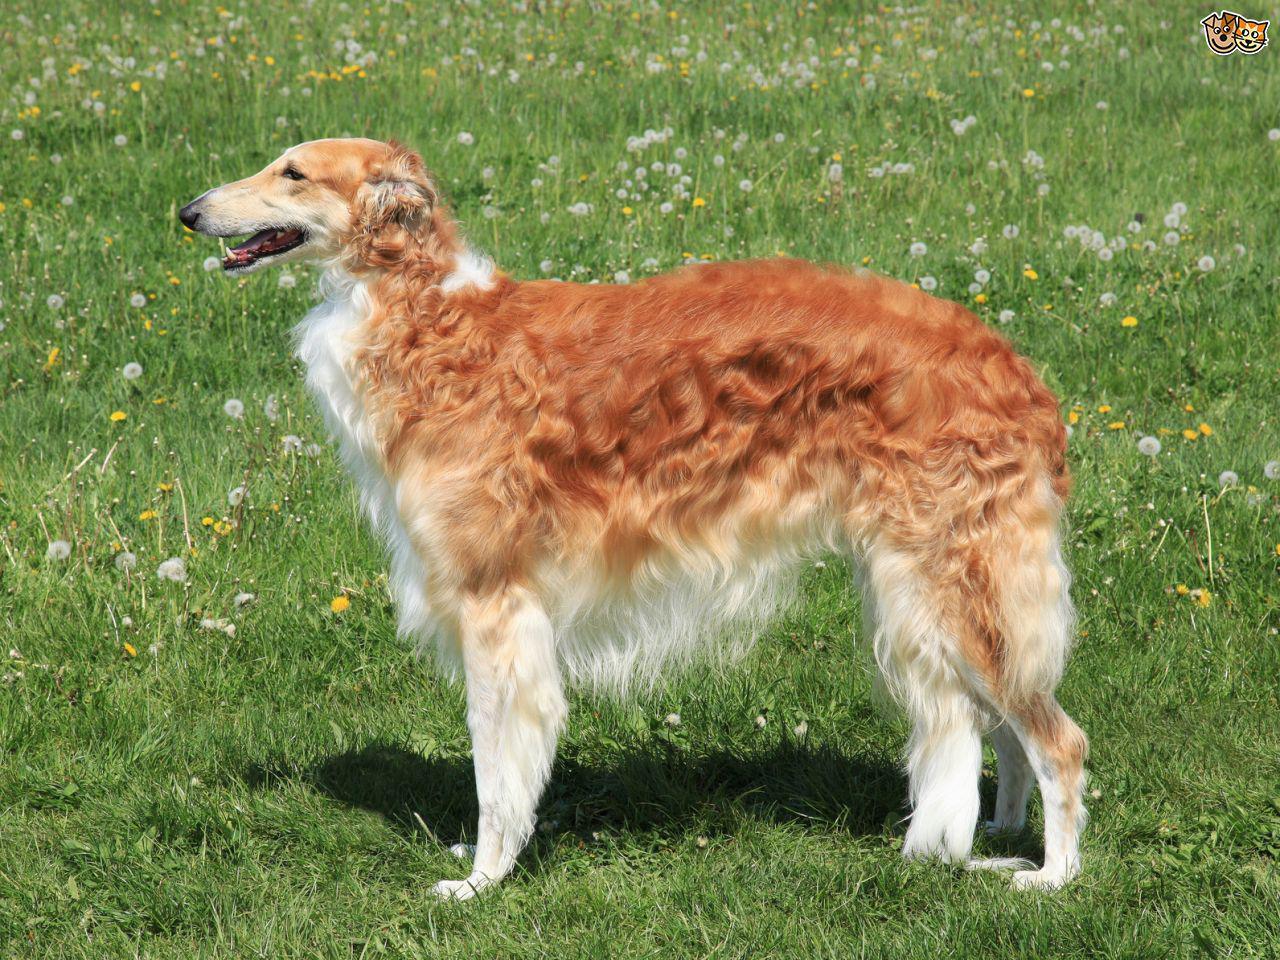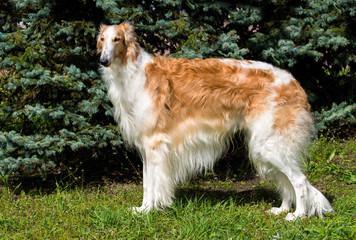The first image is the image on the left, the second image is the image on the right. For the images shown, is this caption "The dogs in the image on the left are facing right." true? Answer yes or no. No. 